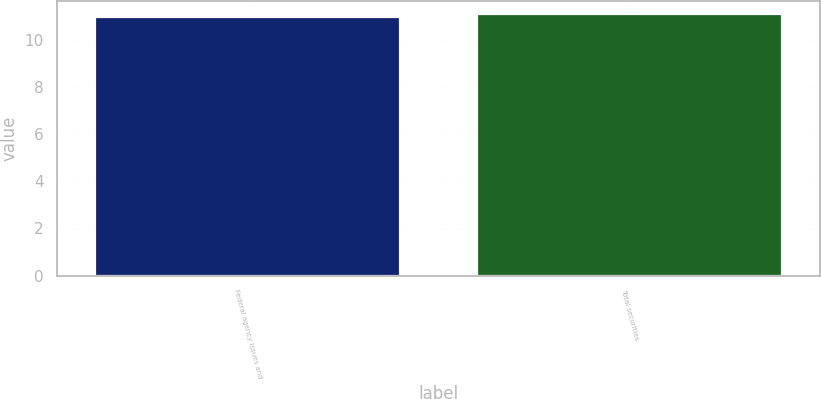Convert chart. <chart><loc_0><loc_0><loc_500><loc_500><bar_chart><fcel>Federal agency issues and<fcel>Total securities<nl><fcel>11<fcel>11.1<nl></chart> 